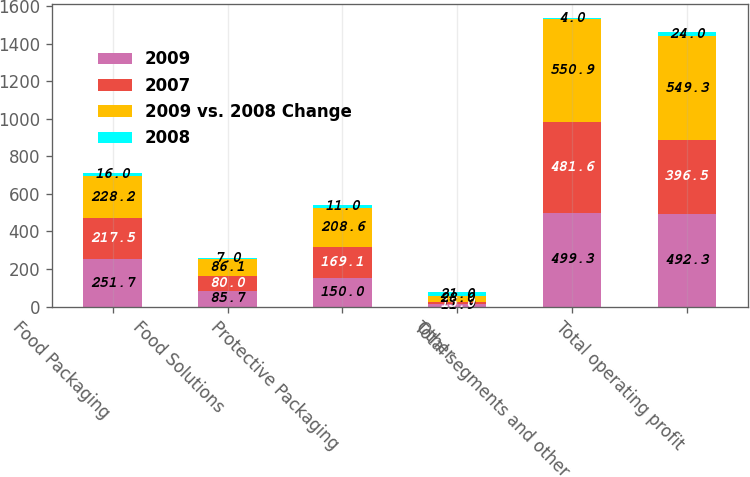Convert chart to OTSL. <chart><loc_0><loc_0><loc_500><loc_500><stacked_bar_chart><ecel><fcel>Food Packaging<fcel>Food Solutions<fcel>Protective Packaging<fcel>Other<fcel>Total segments and other<fcel>Total operating profit<nl><fcel>2009<fcel>251.7<fcel>85.7<fcel>150<fcel>11.9<fcel>499.3<fcel>492.3<nl><fcel>2007<fcel>217.5<fcel>80<fcel>169.1<fcel>15<fcel>481.6<fcel>396.5<nl><fcel>2009 vs. 2008 Change<fcel>228.2<fcel>86.1<fcel>208.6<fcel>28<fcel>550.9<fcel>549.3<nl><fcel>2008<fcel>16<fcel>7<fcel>11<fcel>21<fcel>4<fcel>24<nl></chart> 